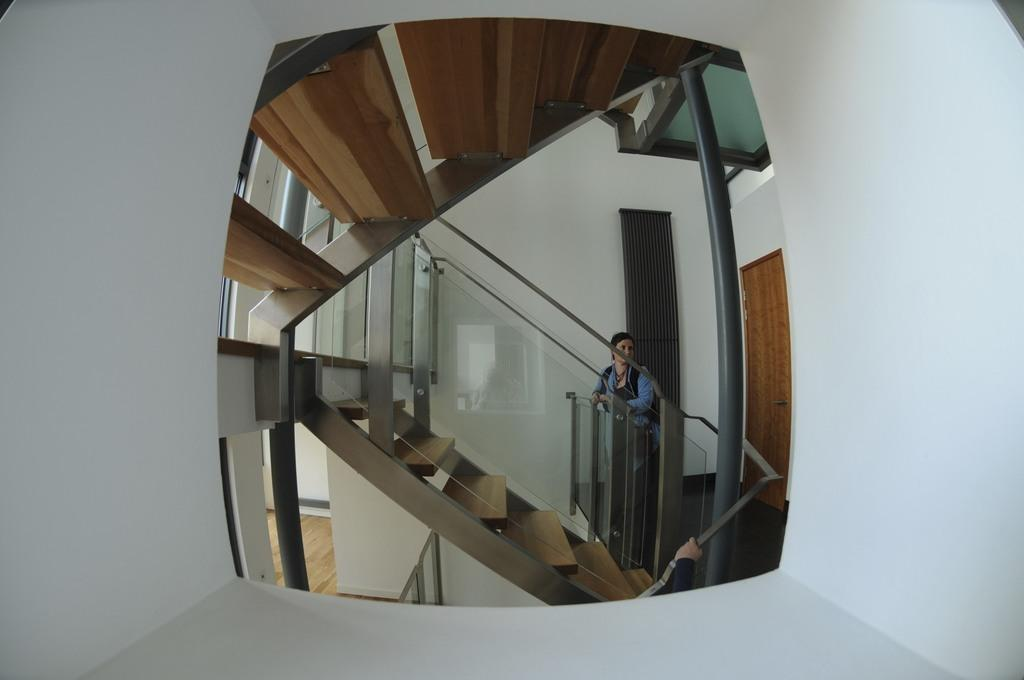Where was the image taken? The image was taken inside a building. Who or what can be seen in the image? There is a person in the image. What architectural feature is present in the image? There are staircases in the image. What can be observed on the glasses in the image? There are reflections on the glasses in the image. What type of quilt is being used to cover the person in the image? There is no quilt present in the image; the person is not covered by any fabric. How does the wax drip from the candles in the image? There are no candles or wax present in the image. 